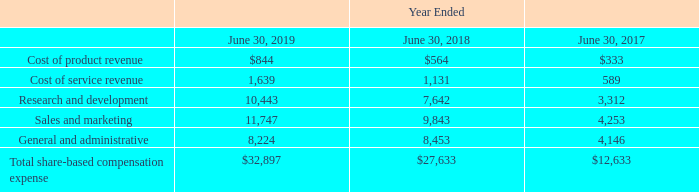Share Based Compensation Expense
Share-based compensation expense recognized in the financial statements by line item caption is as follows (in thousands):
The amount of share-based compensation expense capitalized in inventory has been immaterial for each of the periods presented.
Which years does the table provide information for Share-based compensation expense recognized in the financial statements by line item caption? 2019, 2018, 2017. What was the cost of product revenue in 2017?
Answer scale should be: thousand. 333. What was the amount of research and development in 2019?
Answer scale should be: thousand. 10,443. How many years did Cost of service revenue exceed $1,000 thousand? 2019##2018
Answer: 2. What was the change in cost of product revenue between 2018 and 2019?
Answer scale should be: thousand. 844-564
Answer: 280. What was the percentage change in Sales and marketing between 2017 and 2018?
Answer scale should be: percent. (9,843-4,253)/4,253
Answer: 131.44. 